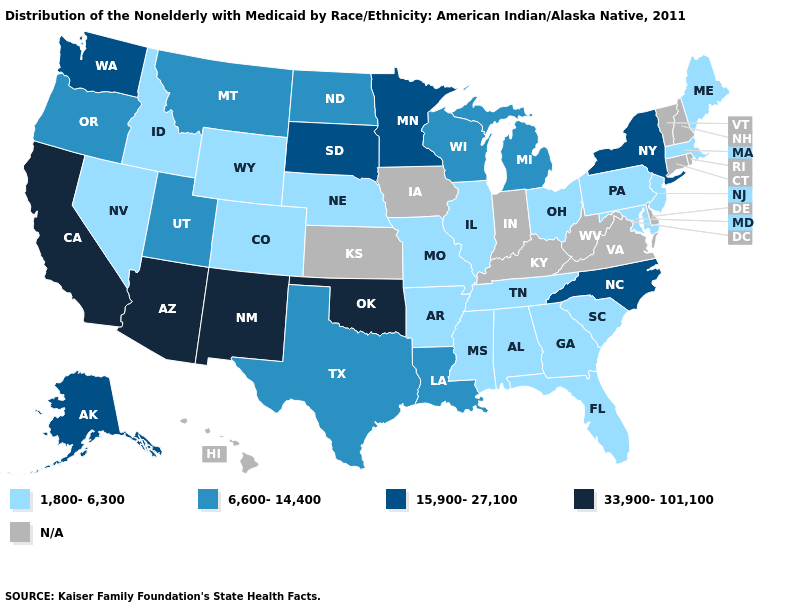What is the lowest value in the USA?
Be succinct. 1,800-6,300. What is the lowest value in the South?
Answer briefly. 1,800-6,300. Does the first symbol in the legend represent the smallest category?
Give a very brief answer. Yes. Name the states that have a value in the range 6,600-14,400?
Write a very short answer. Louisiana, Michigan, Montana, North Dakota, Oregon, Texas, Utah, Wisconsin. What is the lowest value in the USA?
Short answer required. 1,800-6,300. Name the states that have a value in the range 15,900-27,100?
Short answer required. Alaska, Minnesota, New York, North Carolina, South Dakota, Washington. What is the value of Oregon?
Be succinct. 6,600-14,400. Among the states that border Delaware , which have the highest value?
Answer briefly. Maryland, New Jersey, Pennsylvania. What is the value of Mississippi?
Keep it brief. 1,800-6,300. Name the states that have a value in the range 6,600-14,400?
Answer briefly. Louisiana, Michigan, Montana, North Dakota, Oregon, Texas, Utah, Wisconsin. What is the value of Oregon?
Be succinct. 6,600-14,400. Among the states that border California , does Arizona have the highest value?
Short answer required. Yes. Name the states that have a value in the range 15,900-27,100?
Concise answer only. Alaska, Minnesota, New York, North Carolina, South Dakota, Washington. What is the value of Illinois?
Concise answer only. 1,800-6,300. 